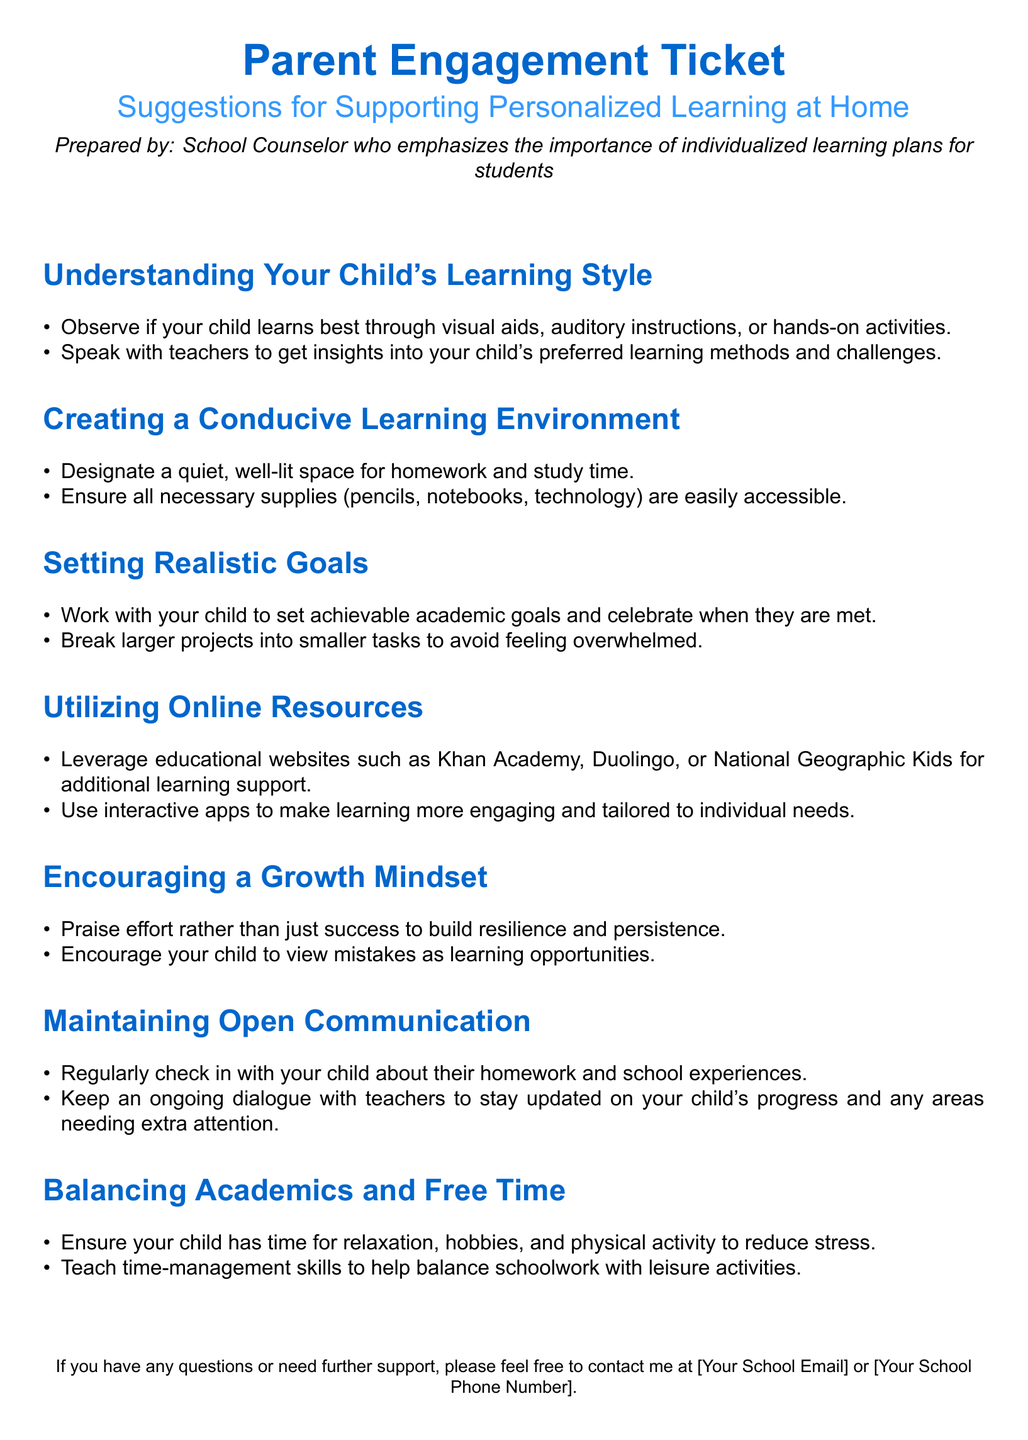What is the title of the document? The title of the document is prominently displayed at the top, introducing the main topic of the document.
Answer: Parent Engagement Ticket Who prepared the suggestions? The author or preparer of the document is mentioned at the end of the title section, indicating their role.
Answer: School Counselor What should be created for a conducive learning environment? The document emphasizes creating specific spaces and conditions for effective learning at home.
Answer: Quiet, well-lit space Which online resource is suggested for additional learning support? The document lists several educational websites where parents can find supplementary learning material.
Answer: Khan Academy What is recommended to encourage in your child regarding mistakes? This aspect emphasizes the mindset that children should adopt towards their learning experiences, particularly with errors.
Answer: Learning opportunities How should academic goals be set? The document provides guidance on how to approach goal-setting with a child in an effective manner.
Answer: Achievable academic goals How often should parents check in with their child about school experiences? This reflects the importance of maintaining communication and support in a child's educational journey.
Answer: Regularly What skill should be taught to help balance schoolwork? This point highlights an important aspect of managing time effectively in relation to academic and personal activities.
Answer: Time-management skills 